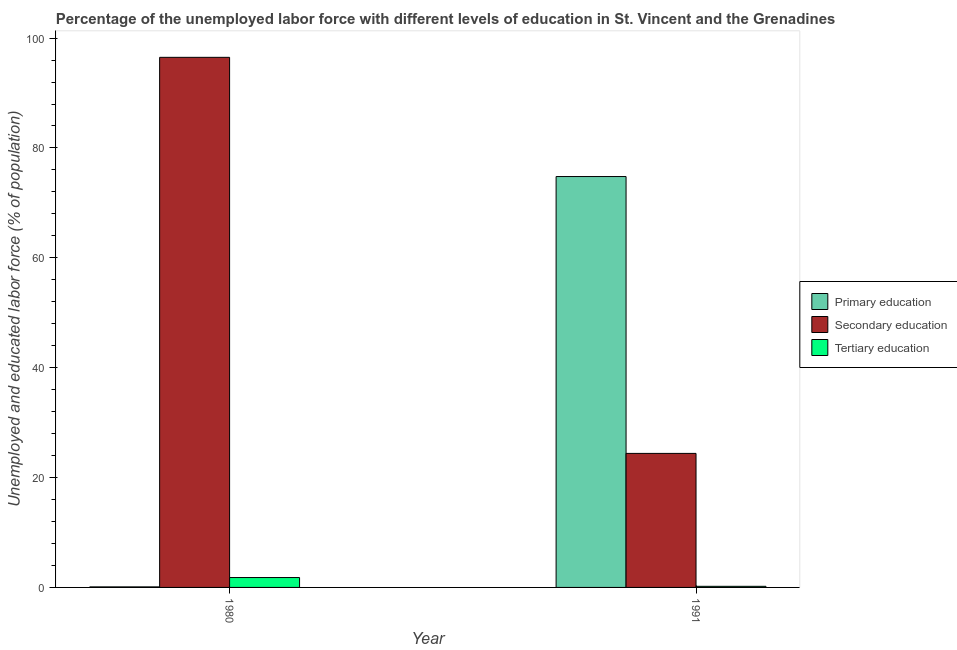How many different coloured bars are there?
Your answer should be very brief. 3. How many groups of bars are there?
Give a very brief answer. 2. Are the number of bars per tick equal to the number of legend labels?
Provide a short and direct response. Yes. How many bars are there on the 2nd tick from the left?
Offer a very short reply. 3. What is the label of the 1st group of bars from the left?
Provide a succinct answer. 1980. In how many cases, is the number of bars for a given year not equal to the number of legend labels?
Your response must be concise. 0. What is the percentage of labor force who received secondary education in 1980?
Provide a succinct answer. 96.5. Across all years, what is the maximum percentage of labor force who received primary education?
Ensure brevity in your answer.  74.8. Across all years, what is the minimum percentage of labor force who received secondary education?
Your answer should be compact. 24.4. In which year was the percentage of labor force who received secondary education maximum?
Your response must be concise. 1980. What is the total percentage of labor force who received secondary education in the graph?
Keep it short and to the point. 120.9. What is the difference between the percentage of labor force who received tertiary education in 1980 and that in 1991?
Provide a succinct answer. 1.6. What is the difference between the percentage of labor force who received secondary education in 1980 and the percentage of labor force who received primary education in 1991?
Your answer should be very brief. 72.1. What is the average percentage of labor force who received secondary education per year?
Offer a terse response. 60.45. In the year 1980, what is the difference between the percentage of labor force who received secondary education and percentage of labor force who received tertiary education?
Offer a terse response. 0. In how many years, is the percentage of labor force who received tertiary education greater than 96 %?
Ensure brevity in your answer.  0. What is the ratio of the percentage of labor force who received primary education in 1980 to that in 1991?
Your answer should be compact. 0. Is the percentage of labor force who received secondary education in 1980 less than that in 1991?
Offer a very short reply. No. In how many years, is the percentage of labor force who received tertiary education greater than the average percentage of labor force who received tertiary education taken over all years?
Make the answer very short. 1. What does the 2nd bar from the right in 1991 represents?
Your answer should be compact. Secondary education. Is it the case that in every year, the sum of the percentage of labor force who received primary education and percentage of labor force who received secondary education is greater than the percentage of labor force who received tertiary education?
Keep it short and to the point. Yes. Are all the bars in the graph horizontal?
Your answer should be very brief. No. How many years are there in the graph?
Your answer should be very brief. 2. What is the difference between two consecutive major ticks on the Y-axis?
Provide a succinct answer. 20. Are the values on the major ticks of Y-axis written in scientific E-notation?
Provide a succinct answer. No. Does the graph contain any zero values?
Provide a succinct answer. No. How many legend labels are there?
Your response must be concise. 3. What is the title of the graph?
Keep it short and to the point. Percentage of the unemployed labor force with different levels of education in St. Vincent and the Grenadines. Does "Social Protection" appear as one of the legend labels in the graph?
Keep it short and to the point. No. What is the label or title of the Y-axis?
Your answer should be compact. Unemployed and educated labor force (% of population). What is the Unemployed and educated labor force (% of population) in Primary education in 1980?
Give a very brief answer. 0.1. What is the Unemployed and educated labor force (% of population) of Secondary education in 1980?
Ensure brevity in your answer.  96.5. What is the Unemployed and educated labor force (% of population) in Tertiary education in 1980?
Your response must be concise. 1.8. What is the Unemployed and educated labor force (% of population) in Primary education in 1991?
Your answer should be compact. 74.8. What is the Unemployed and educated labor force (% of population) in Secondary education in 1991?
Offer a very short reply. 24.4. What is the Unemployed and educated labor force (% of population) of Tertiary education in 1991?
Make the answer very short. 0.2. Across all years, what is the maximum Unemployed and educated labor force (% of population) in Primary education?
Offer a terse response. 74.8. Across all years, what is the maximum Unemployed and educated labor force (% of population) in Secondary education?
Give a very brief answer. 96.5. Across all years, what is the maximum Unemployed and educated labor force (% of population) in Tertiary education?
Make the answer very short. 1.8. Across all years, what is the minimum Unemployed and educated labor force (% of population) in Primary education?
Offer a very short reply. 0.1. Across all years, what is the minimum Unemployed and educated labor force (% of population) of Secondary education?
Your answer should be compact. 24.4. Across all years, what is the minimum Unemployed and educated labor force (% of population) of Tertiary education?
Provide a short and direct response. 0.2. What is the total Unemployed and educated labor force (% of population) in Primary education in the graph?
Offer a terse response. 74.9. What is the total Unemployed and educated labor force (% of population) in Secondary education in the graph?
Make the answer very short. 120.9. What is the difference between the Unemployed and educated labor force (% of population) in Primary education in 1980 and that in 1991?
Provide a short and direct response. -74.7. What is the difference between the Unemployed and educated labor force (% of population) in Secondary education in 1980 and that in 1991?
Give a very brief answer. 72.1. What is the difference between the Unemployed and educated labor force (% of population) of Primary education in 1980 and the Unemployed and educated labor force (% of population) of Secondary education in 1991?
Offer a terse response. -24.3. What is the difference between the Unemployed and educated labor force (% of population) in Primary education in 1980 and the Unemployed and educated labor force (% of population) in Tertiary education in 1991?
Your answer should be very brief. -0.1. What is the difference between the Unemployed and educated labor force (% of population) of Secondary education in 1980 and the Unemployed and educated labor force (% of population) of Tertiary education in 1991?
Provide a short and direct response. 96.3. What is the average Unemployed and educated labor force (% of population) in Primary education per year?
Offer a very short reply. 37.45. What is the average Unemployed and educated labor force (% of population) of Secondary education per year?
Provide a succinct answer. 60.45. What is the average Unemployed and educated labor force (% of population) in Tertiary education per year?
Your response must be concise. 1. In the year 1980, what is the difference between the Unemployed and educated labor force (% of population) in Primary education and Unemployed and educated labor force (% of population) in Secondary education?
Offer a terse response. -96.4. In the year 1980, what is the difference between the Unemployed and educated labor force (% of population) of Secondary education and Unemployed and educated labor force (% of population) of Tertiary education?
Your answer should be very brief. 94.7. In the year 1991, what is the difference between the Unemployed and educated labor force (% of population) in Primary education and Unemployed and educated labor force (% of population) in Secondary education?
Your answer should be compact. 50.4. In the year 1991, what is the difference between the Unemployed and educated labor force (% of population) in Primary education and Unemployed and educated labor force (% of population) in Tertiary education?
Make the answer very short. 74.6. In the year 1991, what is the difference between the Unemployed and educated labor force (% of population) of Secondary education and Unemployed and educated labor force (% of population) of Tertiary education?
Provide a short and direct response. 24.2. What is the ratio of the Unemployed and educated labor force (% of population) of Primary education in 1980 to that in 1991?
Your answer should be compact. 0. What is the ratio of the Unemployed and educated labor force (% of population) in Secondary education in 1980 to that in 1991?
Your answer should be very brief. 3.95. What is the difference between the highest and the second highest Unemployed and educated labor force (% of population) of Primary education?
Your answer should be very brief. 74.7. What is the difference between the highest and the second highest Unemployed and educated labor force (% of population) of Secondary education?
Give a very brief answer. 72.1. What is the difference between the highest and the second highest Unemployed and educated labor force (% of population) in Tertiary education?
Provide a succinct answer. 1.6. What is the difference between the highest and the lowest Unemployed and educated labor force (% of population) of Primary education?
Keep it short and to the point. 74.7. What is the difference between the highest and the lowest Unemployed and educated labor force (% of population) in Secondary education?
Provide a succinct answer. 72.1. What is the difference between the highest and the lowest Unemployed and educated labor force (% of population) of Tertiary education?
Provide a short and direct response. 1.6. 